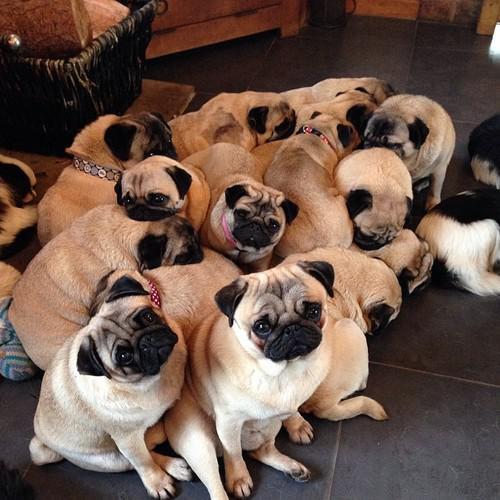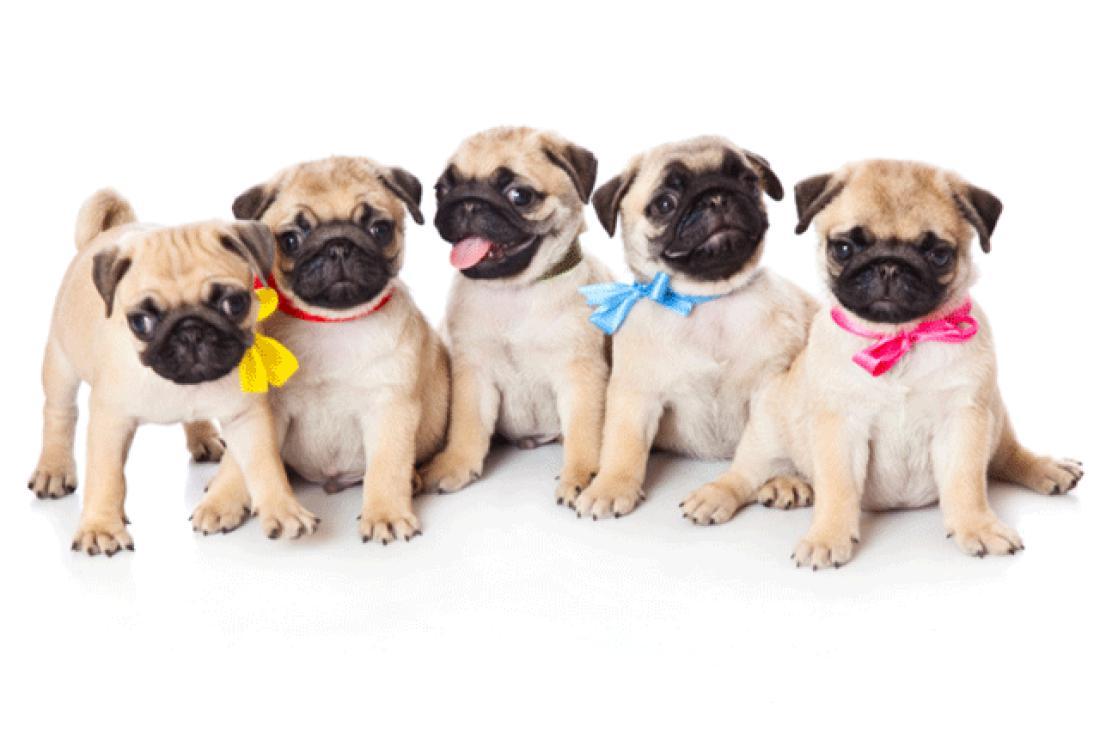The first image is the image on the left, the second image is the image on the right. Analyze the images presented: Is the assertion "There are exactly five dogs in one of the images." valid? Answer yes or no. Yes. 